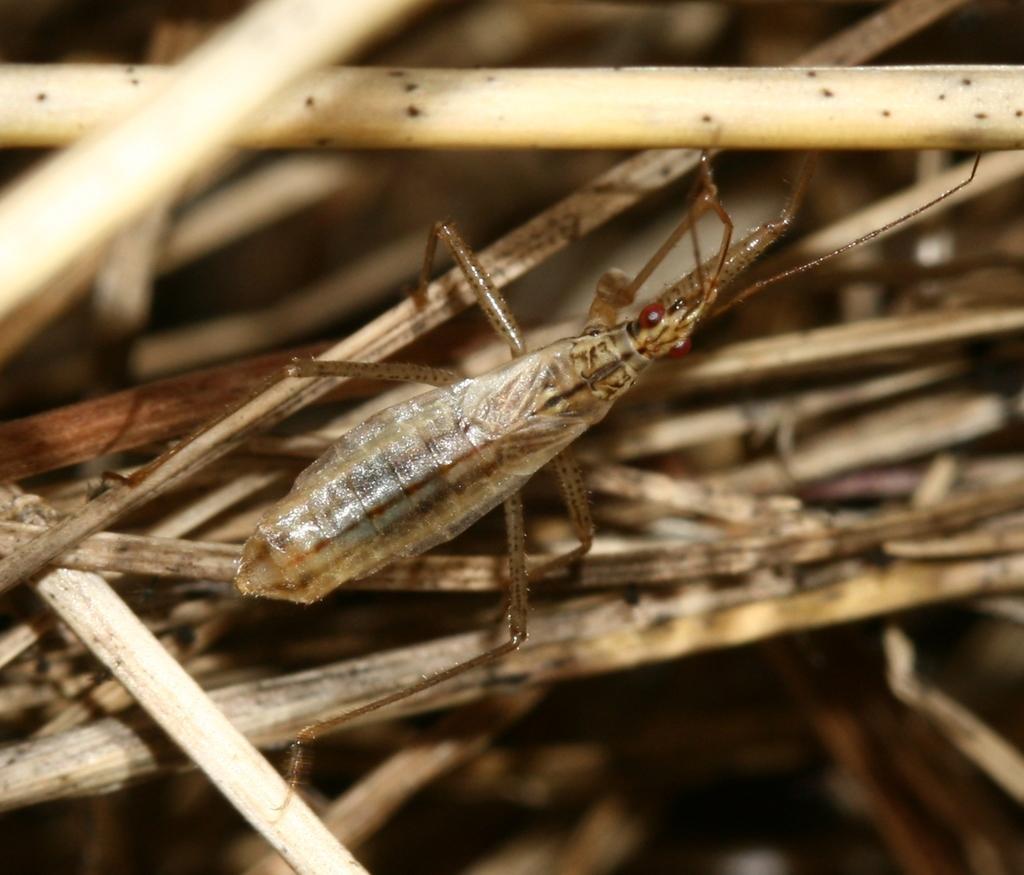Can you describe this image briefly? In this image there is an insect on dry sticks. 